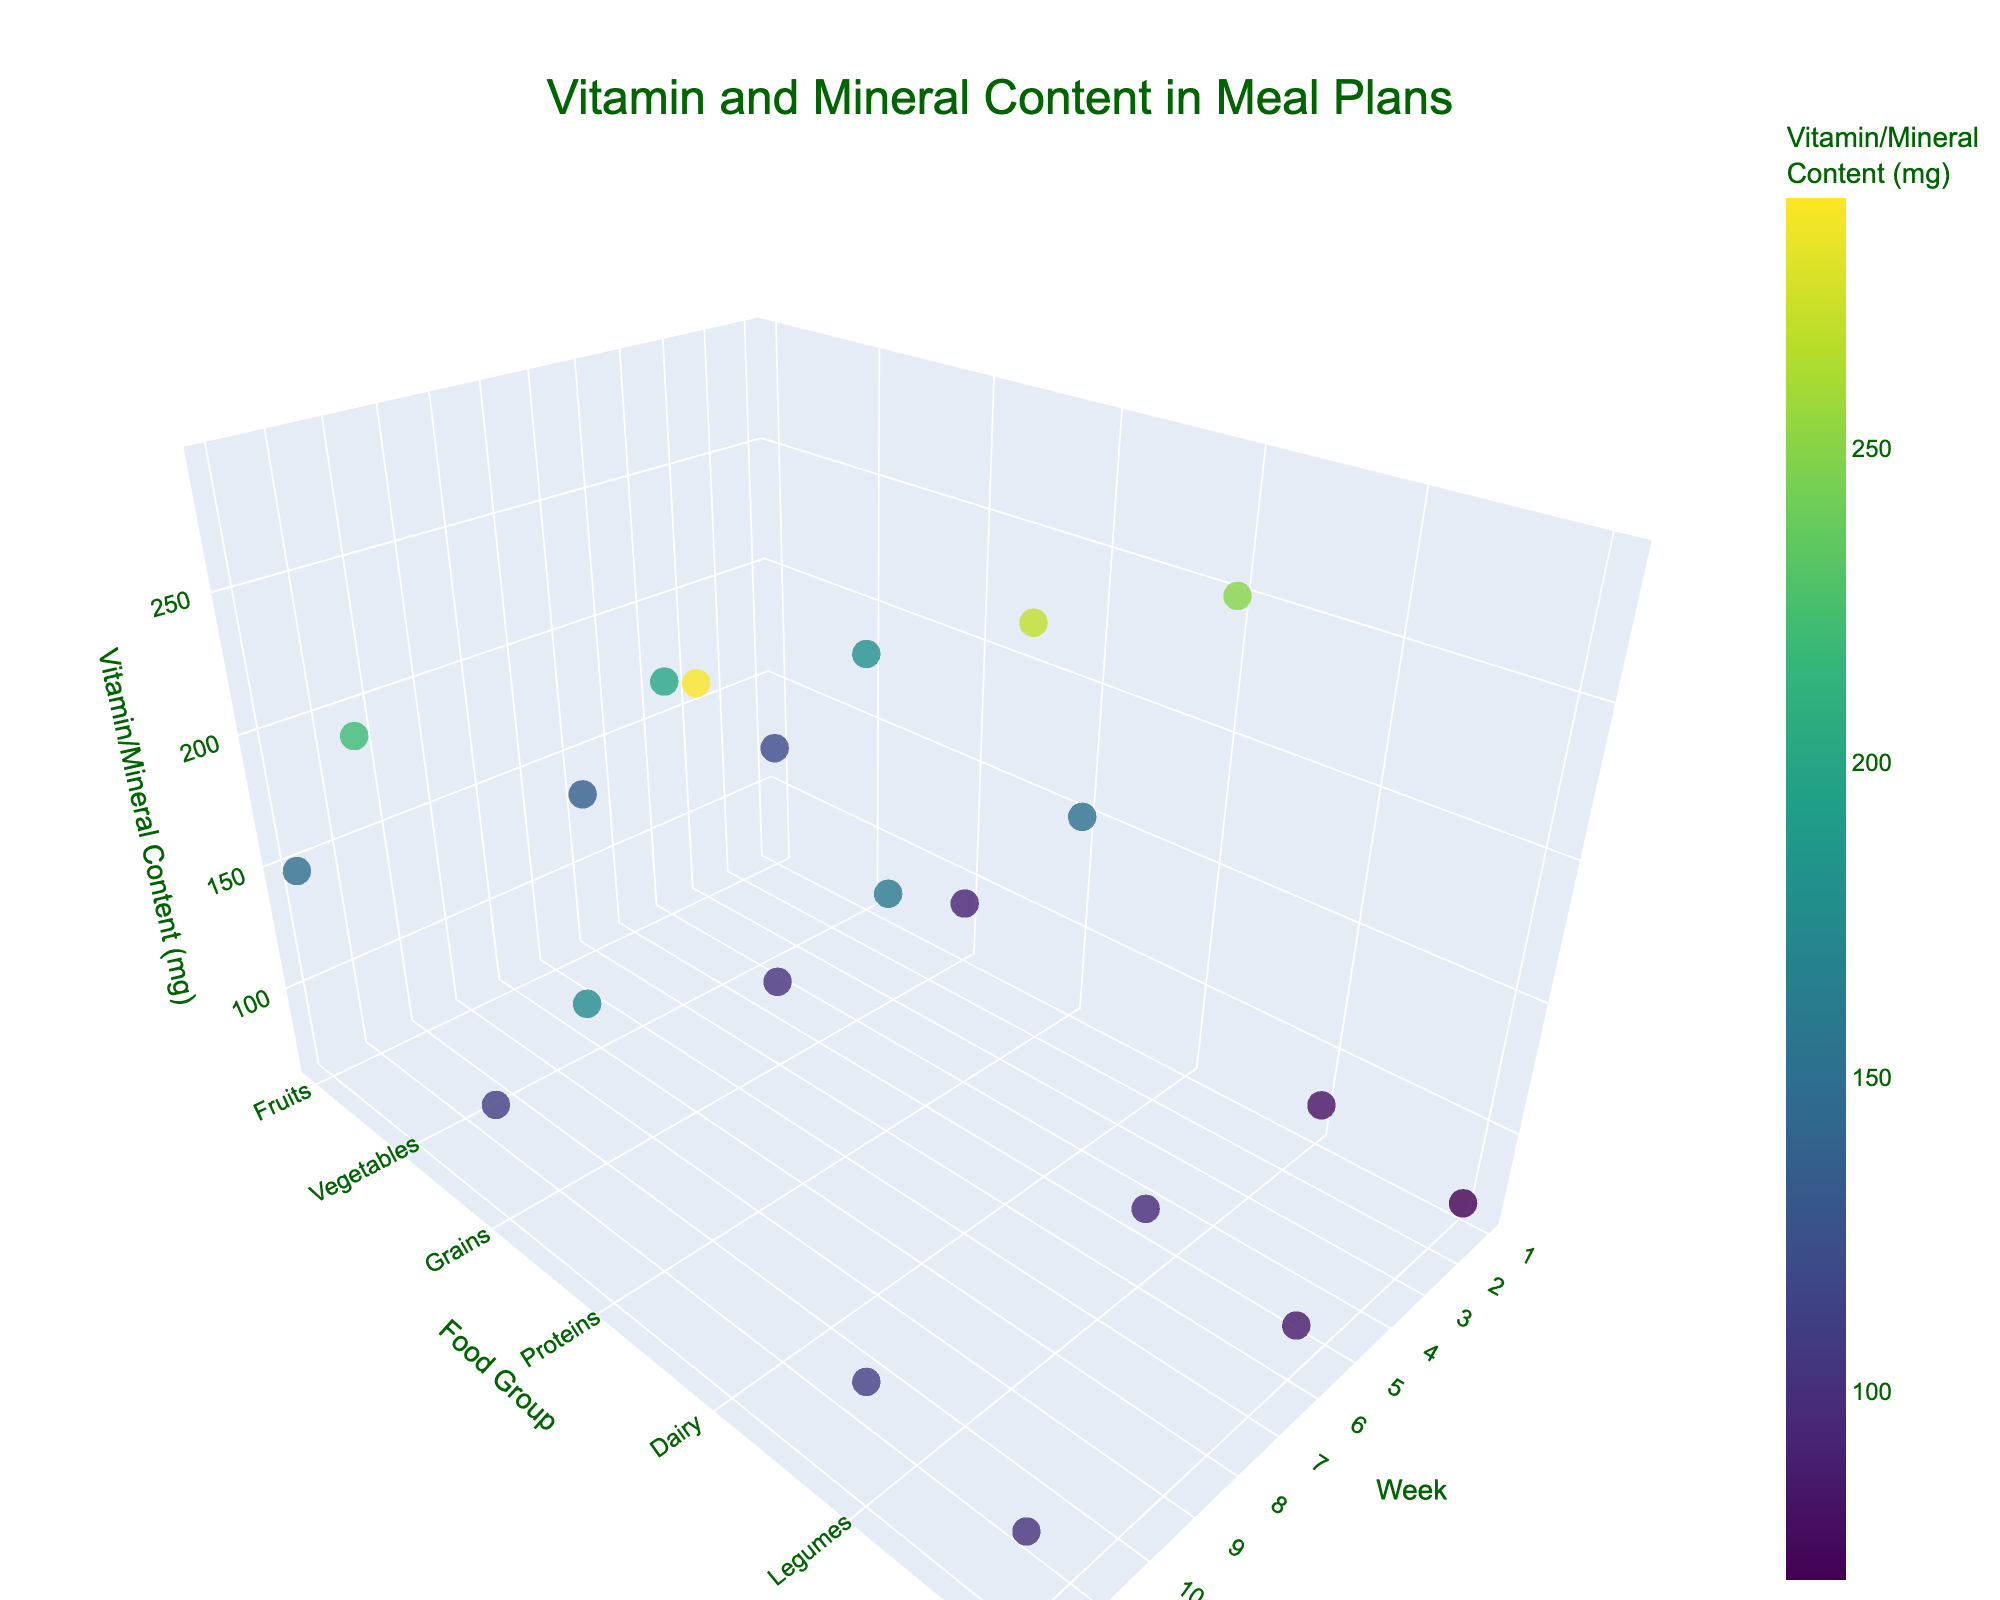What is the title of the figure? The title of the figure is usually displayed prominently at the top and summarizes the main content of the graph. In this case, it reads "Vitamin and Mineral Content in Meal Plans".
Answer: Vitamin and Mineral Content in Meal Plans What food group has the highest Vitamin/Mineral content in Week 1? To determine this, we compare the Vitamin/Mineral content values in Week 1 across all food groups. The highest value is 250 mg from the dairy group.
Answer: Dairy How does the Vitamin/Mineral content of Vegetables change from Week 1 to Week 12? To find this, look at the Vitamin/Mineral content for Vegetables in Week 1, 6, and 12, which are 180 mg, 200 mg, and 220 mg respectively. The content increases by 20 mg from Week 1 to Week 6 and by another 20 mg from Week 6 to Week 12.
Answer: It increases consistently Which week has the highest overall Vitamin/Mineral content across all food groups? Summing the Vitamin/Mineral contents for all food groups in each week: Week 1 (940 mg), Week 6 (1145 mg), and Week 12 (1225 mg). Week 12 has the highest overall content.
Answer: Week 12 Does the Vitamin/Mineral content in Nuts and Seeds surpass the content in Grains in any week? Comparing the values for Nuts and Seeds and Grains weekly: 
- Week 1: 70 mg vs. 90 mg
- Week 6: 85 mg vs. 100 mg
- Week 12: 100 mg vs. 110 mg 
The content in Nuts and Seeds is always lower than in Grains.
Answer: No What is the median Vitamin/Mineral content for Legumes across the semester? To calculate the median, order the contents for Legumes: 80 mg, 95 mg, 110 mg. The median is the middle value, which is 95 mg.
Answer: 95 mg How many data points are there in total in the figure? Each food group has data points for Week 1, Week 6, and Week 12. Since there are 7 food groups, multiply 7 by 3, resulting in 21 data points in total.
Answer: 21 Which food group has the lowest Vitamin/Mineral content in Week 6? By examining the content values for Week 6, we find that Nuts and Seeds have the lowest content at 85 mg.
Answer: Nuts and Seeds How does the Vitamin/Mineral content of Proteins compare between Week 6 and Week 12? The Vitamin/Mineral content for Proteins in Week 6 is 160 mg, and in Week 12, it is 175 mg. The content increases by 15 mg from Week 6 to Week 12.
Answer: It increases by 15 mg 